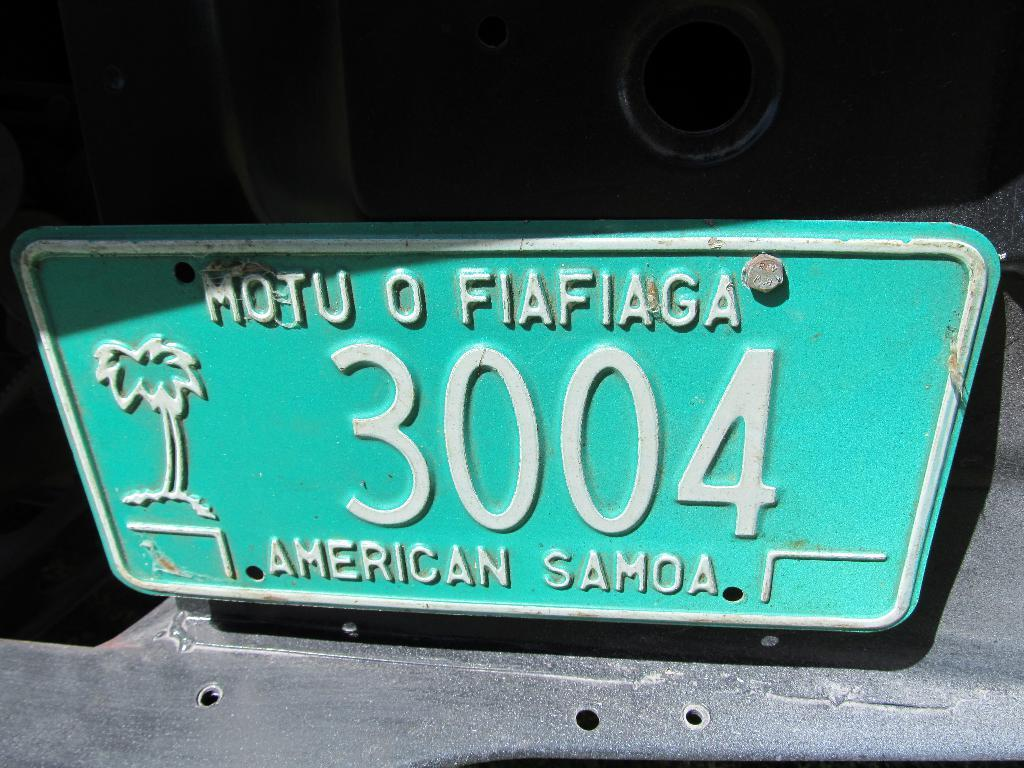<image>
Relay a brief, clear account of the picture shown. A green American Samoa licence plate with a palm tree 